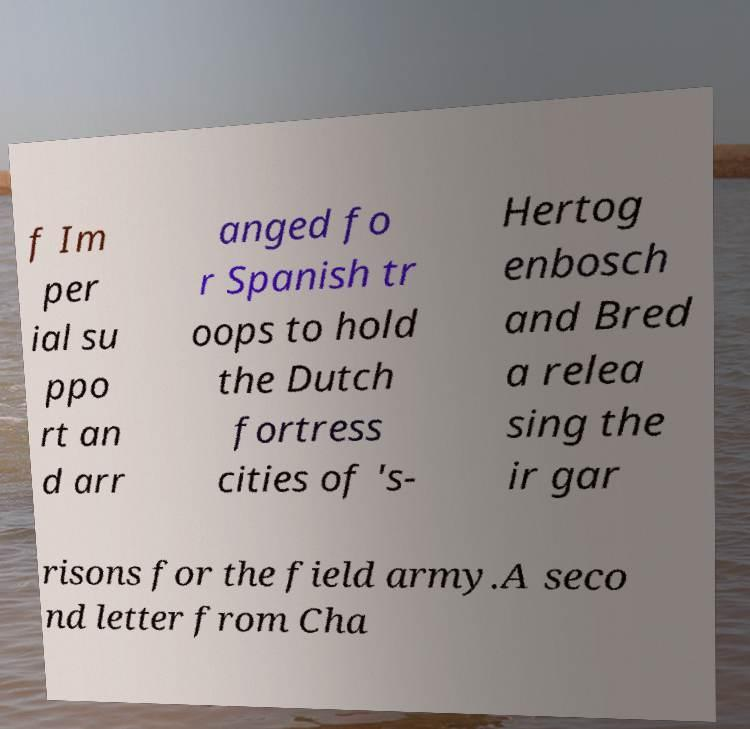Please identify and transcribe the text found in this image. f Im per ial su ppo rt an d arr anged fo r Spanish tr oops to hold the Dutch fortress cities of 's- Hertog enbosch and Bred a relea sing the ir gar risons for the field army.A seco nd letter from Cha 